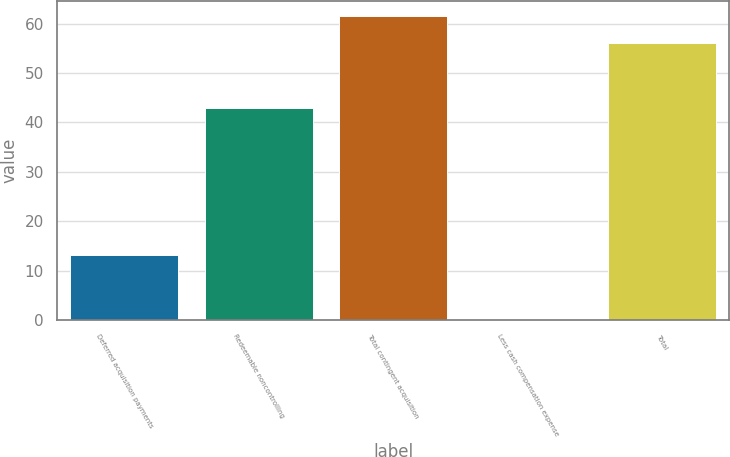Convert chart. <chart><loc_0><loc_0><loc_500><loc_500><bar_chart><fcel>Deferred acquisition payments<fcel>Redeemable noncontrolling<fcel>Total contingent acquisition<fcel>Less cash compensation expense<fcel>Total<nl><fcel>13.1<fcel>43<fcel>61.6<fcel>0.1<fcel>56<nl></chart> 